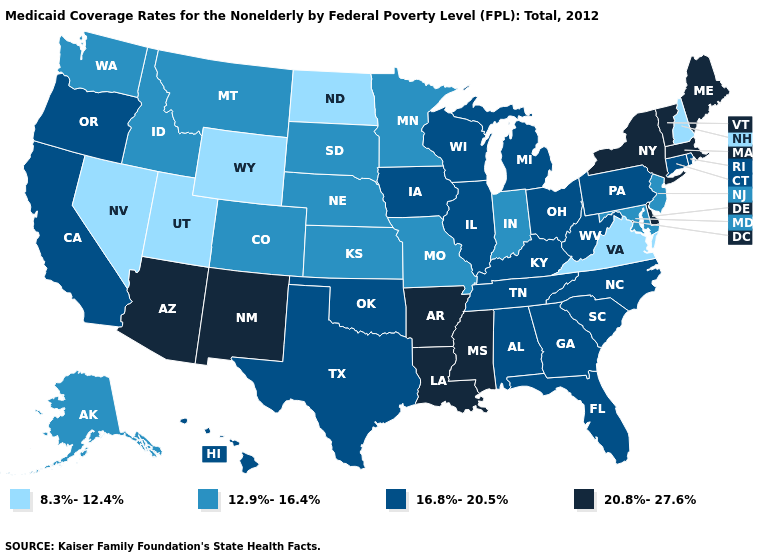What is the lowest value in states that border North Carolina?
Quick response, please. 8.3%-12.4%. Does Virginia have the lowest value in the USA?
Give a very brief answer. Yes. Name the states that have a value in the range 12.9%-16.4%?
Be succinct. Alaska, Colorado, Idaho, Indiana, Kansas, Maryland, Minnesota, Missouri, Montana, Nebraska, New Jersey, South Dakota, Washington. What is the value of Wisconsin?
Concise answer only. 16.8%-20.5%. Among the states that border Montana , does South Dakota have the highest value?
Concise answer only. Yes. What is the value of California?
Keep it brief. 16.8%-20.5%. What is the highest value in the Northeast ?
Concise answer only. 20.8%-27.6%. Which states have the lowest value in the MidWest?
Give a very brief answer. North Dakota. What is the highest value in the Northeast ?
Answer briefly. 20.8%-27.6%. Among the states that border Illinois , does Missouri have the lowest value?
Short answer required. Yes. Does New York have the highest value in the Northeast?
Concise answer only. Yes. What is the lowest value in the USA?
Write a very short answer. 8.3%-12.4%. Name the states that have a value in the range 16.8%-20.5%?
Quick response, please. Alabama, California, Connecticut, Florida, Georgia, Hawaii, Illinois, Iowa, Kentucky, Michigan, North Carolina, Ohio, Oklahoma, Oregon, Pennsylvania, Rhode Island, South Carolina, Tennessee, Texas, West Virginia, Wisconsin. What is the value of Maryland?
Write a very short answer. 12.9%-16.4%. What is the value of Massachusetts?
Short answer required. 20.8%-27.6%. 